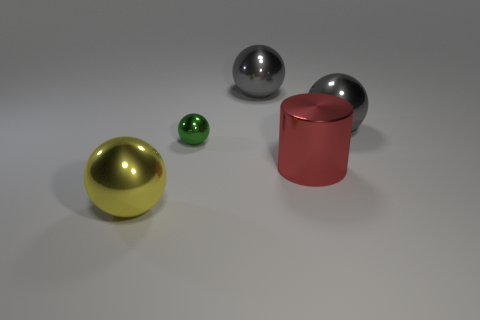Imagine this is an art piece. What title would you give it and why? If this were an art piece, I might title it 'Spectrum of Elegance.' This title encapsulates the diversity of colors and textures, ranging from the reflective sheen of metallic surfaces to the transparent, glass-like appearance of the smallest ball. The arrangement suggests a harmonious yet dynamic interplay of shapes and materials—a celebration of simplistic beauty. 